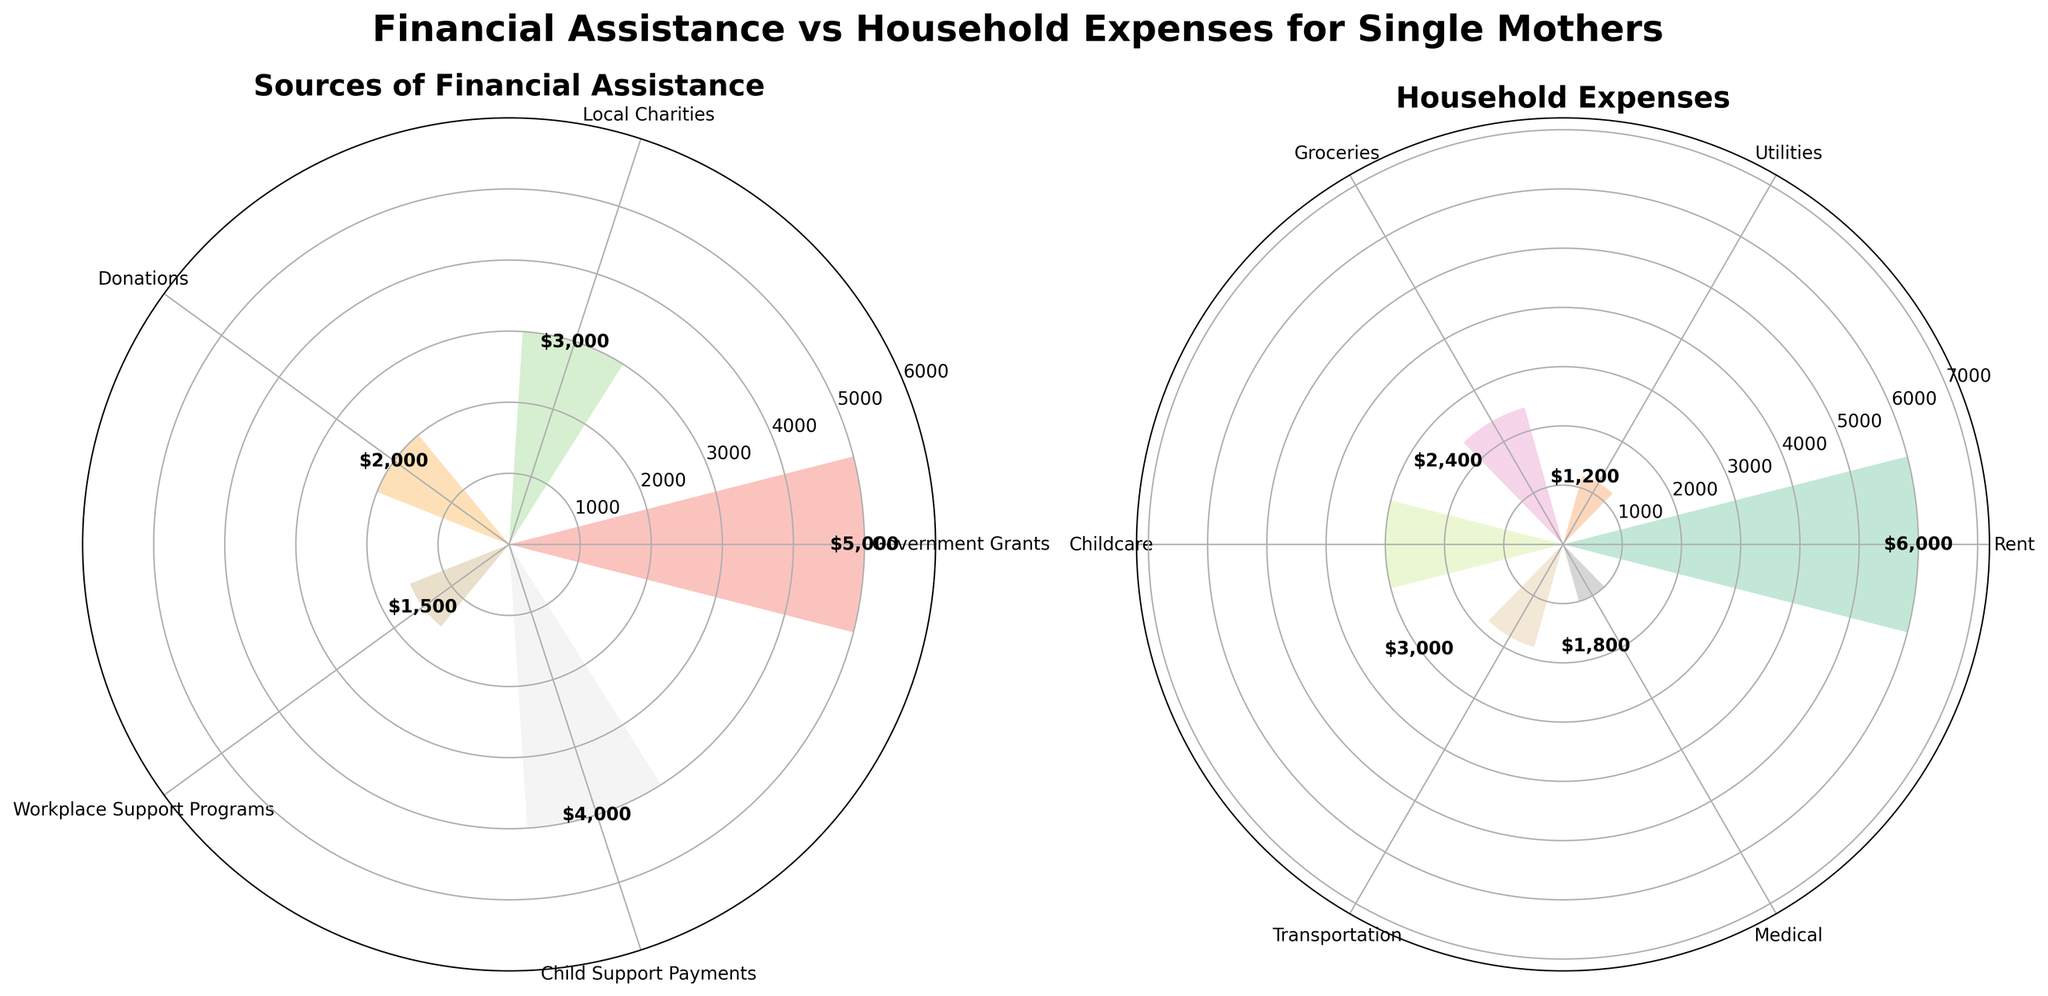What is the title of the left polar chart? The title of the left polar chart is displayed at the top of the panel. It reads 'Sources of Financial Assistance'.
Answer: Sources of Financial Assistance What is the largest household expense? By looking at the bars in the right polar chart, the longest bar corresponds to rent, indicating that rent is the largest household expense.
Answer: Rent How much assistance is provided by local charities? The bar for 'Local Charities' in the left polar chart shows a value of 3,000.
Answer: 3,000 What is the total amount of financial assistance from government grants and donations? The assistance from government grants is 5,000 and from donations is 2,000. Adding these together gives 5,000 + 2,000 = 7,000.
Answer: 7,000 Which source of financial assistance is greater: workplace support programs or child support payments? Comparing the bars for 'Workplace Support Programs' and 'Child Support Payments' in the left polar chart, the bar for child support payments is longer. The amounts are 1,500 and 4,000, respectively, so child support payments are greater.
Answer: Child Support Payments What household expense is closest in value to childcare costs? In the right polar chart, childcare costs 3,000. Comparing this to other bars, groceries, which cost 2,400, are closest.
Answer: Groceries What is the total amount of household expenses? Summing the amounts of all household expenses: 6,000 (Rent) + 1,200 (Utilities) + 2,400 (Groceries) + 3,000 (Childcare) + 1,800 (Transportation) + 1,000 (Medical) = 15,400.
Answer: 15,400 Is the combined financial assistance from local charities and workplace support programs more or less than the rent expense? Local charities provide 3,000 and workplace support programs provide 1,500. Combined, they amount to 4,500. The rent expense is 6,000 which is more than 4,500.
Answer: Less Which has the smallest category in financial assistance? In the left polar chart, the shortest bar corresponds to 'Workplace Support Programs' with a value of 1,500, indicating it is the smallest category in financial assistance.
Answer: Workplace Support Programs Are the medical expenses greater than the donations received? Medical expenses are 1,000, while donations amount to 2,000. Thus, medical expenses are less than donations.
Answer: No 